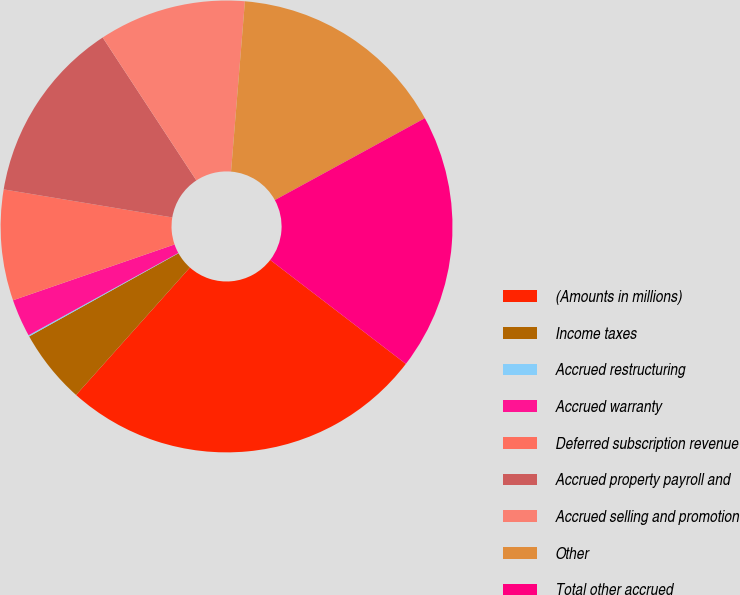Convert chart. <chart><loc_0><loc_0><loc_500><loc_500><pie_chart><fcel>(Amounts in millions)<fcel>Income taxes<fcel>Accrued restructuring<fcel>Accrued warranty<fcel>Deferred subscription revenue<fcel>Accrued property payroll and<fcel>Accrued selling and promotion<fcel>Other<fcel>Total other accrued<nl><fcel>26.19%<fcel>5.31%<fcel>0.09%<fcel>2.7%<fcel>7.92%<fcel>13.14%<fcel>10.53%<fcel>15.75%<fcel>18.36%<nl></chart> 